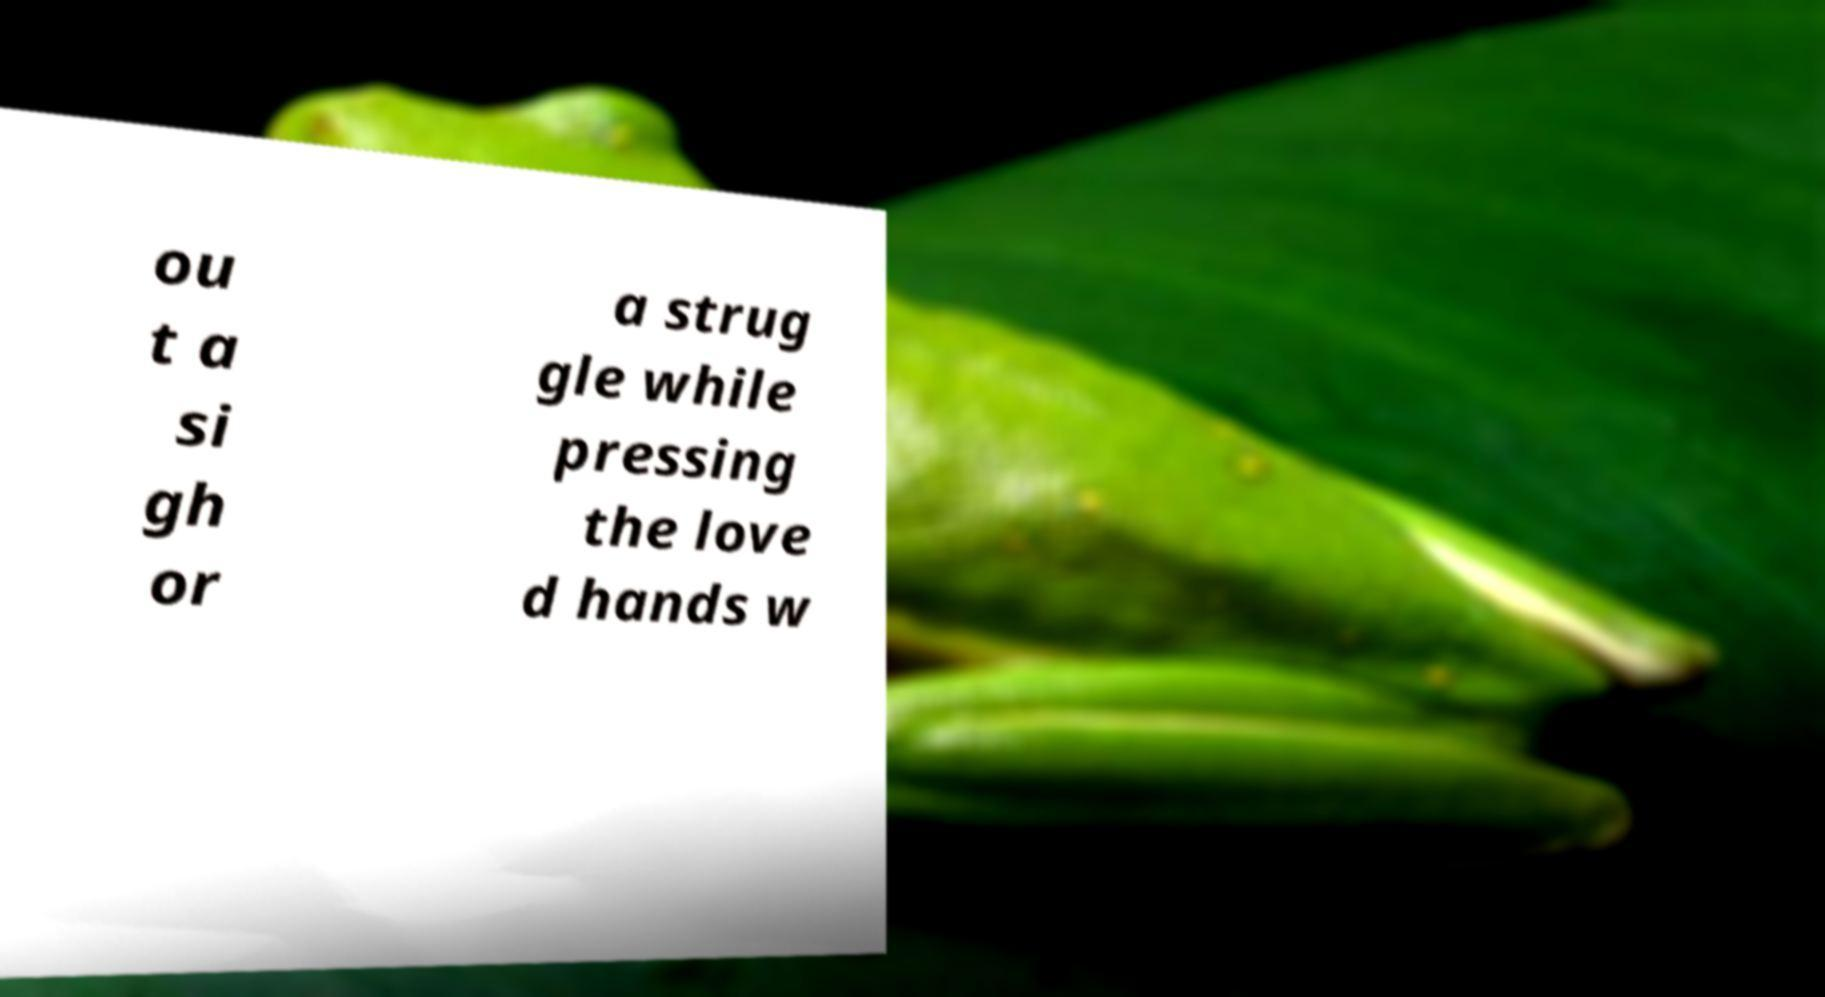For documentation purposes, I need the text within this image transcribed. Could you provide that? ou t a si gh or a strug gle while pressing the love d hands w 